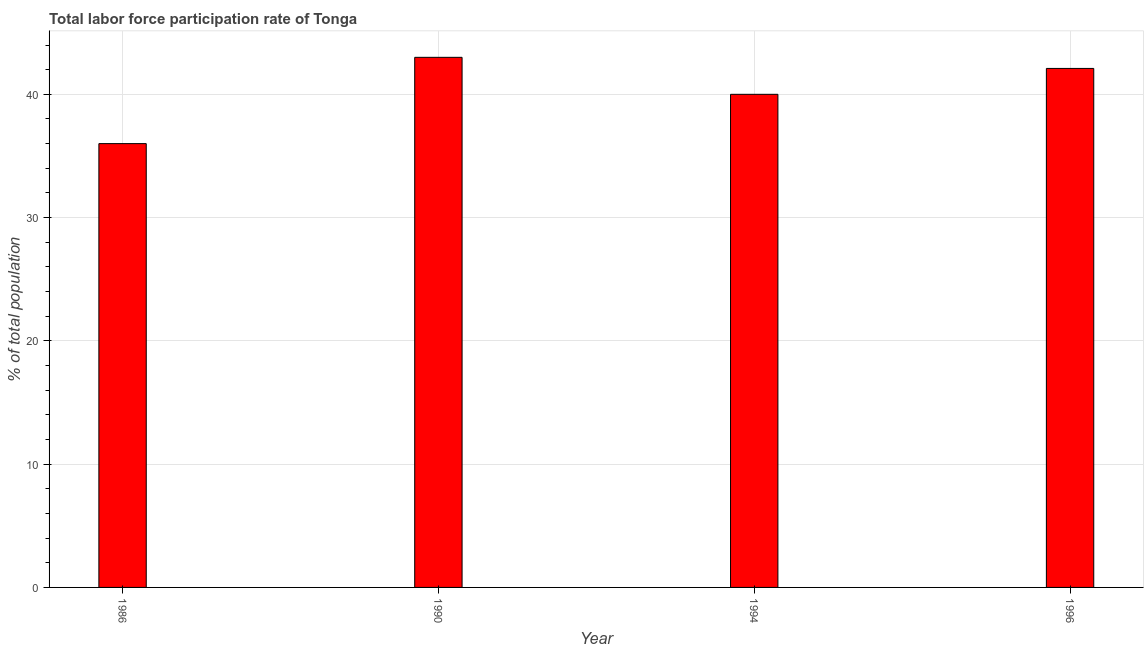Does the graph contain any zero values?
Provide a short and direct response. No. Does the graph contain grids?
Make the answer very short. Yes. What is the title of the graph?
Provide a succinct answer. Total labor force participation rate of Tonga. What is the label or title of the Y-axis?
Give a very brief answer. % of total population. What is the total labor force participation rate in 1990?
Ensure brevity in your answer.  43. In which year was the total labor force participation rate maximum?
Make the answer very short. 1990. In which year was the total labor force participation rate minimum?
Give a very brief answer. 1986. What is the sum of the total labor force participation rate?
Your answer should be compact. 161.1. What is the difference between the total labor force participation rate in 1986 and 1994?
Provide a short and direct response. -4. What is the average total labor force participation rate per year?
Provide a short and direct response. 40.27. What is the median total labor force participation rate?
Provide a short and direct response. 41.05. In how many years, is the total labor force participation rate greater than 10 %?
Keep it short and to the point. 4. Do a majority of the years between 1990 and 1994 (inclusive) have total labor force participation rate greater than 6 %?
Provide a succinct answer. Yes. Is the difference between the total labor force participation rate in 1990 and 1994 greater than the difference between any two years?
Ensure brevity in your answer.  No. What is the difference between the highest and the second highest total labor force participation rate?
Make the answer very short. 0.9. In how many years, is the total labor force participation rate greater than the average total labor force participation rate taken over all years?
Provide a short and direct response. 2. Are all the bars in the graph horizontal?
Give a very brief answer. No. What is the difference between two consecutive major ticks on the Y-axis?
Offer a very short reply. 10. What is the % of total population of 1996?
Your answer should be compact. 42.1. What is the difference between the % of total population in 1986 and 1996?
Your response must be concise. -6.1. What is the difference between the % of total population in 1990 and 1994?
Offer a terse response. 3. What is the difference between the % of total population in 1994 and 1996?
Your answer should be compact. -2.1. What is the ratio of the % of total population in 1986 to that in 1990?
Provide a short and direct response. 0.84. What is the ratio of the % of total population in 1986 to that in 1996?
Make the answer very short. 0.85. What is the ratio of the % of total population in 1990 to that in 1994?
Your answer should be very brief. 1.07. 